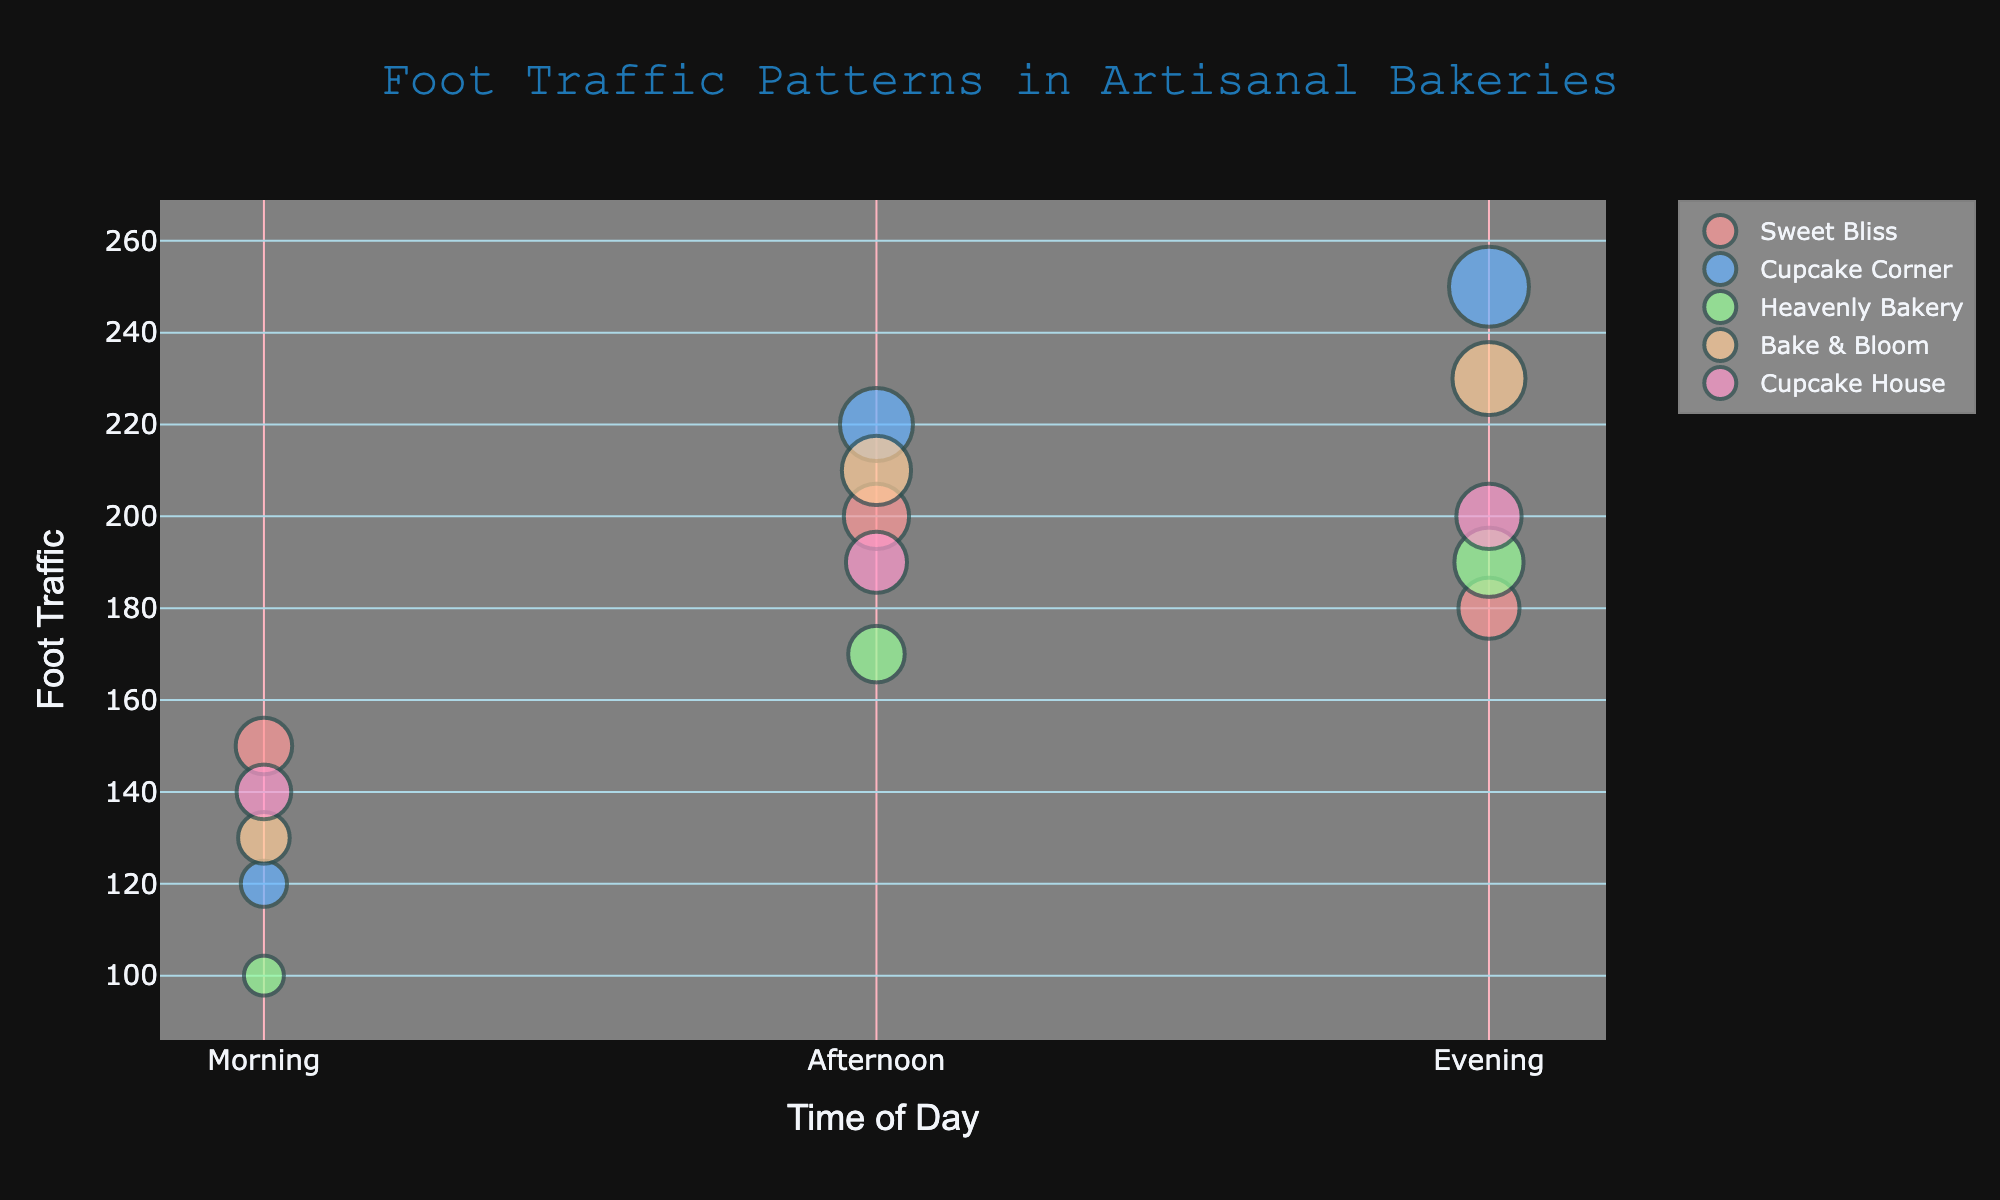What's the title of the figure? Look at the title displayed prominently at the top of the plot.
Answer: Foot Traffic Patterns in Artisanal Bakeries What does the size of the bubbles represent? The legend and the explanatory text on hover indicate the meaning of the bubble size.
Answer: Cupcake Sales Which bakery has the highest foot traffic in the evening? By comparing the positions along the y-axis for the "Evening" entries of each bakery, we see that Cupcake Corner has the highest foot traffic.
Answer: Cupcake Corner What time of day does Sweet Bliss have the highest foot traffic? Locate the markers for Sweet Bliss and compare the y-values for Morning, Afternoon, and Evening times.
Answer: Afternoon Which bakery has the smallest bubble in the morning session? Compare the sizes of the bubbles at the "Morning" time for each bakery. The smallest bubble indicates the lowest cupcake sales.
Answer: Heavenly Bakery What trend can be observed in foot traffic for Bake & Bloom throughout the day? Analyze the y-values for Bake & Bloom at different times of the day to identify any increasing or decreasing trends.
Answer: Increasing How much does foot traffic increase for Cupcake Corner from morning to afternoon? Look at the y-values for Cupcake Corner in the "Morning" and "Afternoon". Calculate the difference. 220 (Afternoon) - 120 (Morning) = 100
Answer: 100 Which bakery has the largest cupcake sales in the afternoon, and what is the bubble size? Compare the sizes of the bubbles at the "Afternoon" time for each bakery. The largest bubble corresponds to the highest cupcake sales.
Answer: Cupcake Corner, 50 How do cupcake sales at Cupcake House compare between morning and evening? Compare the sizes of the bubbles for Cupcake House at "Morning" and "Evening". The bubble sizes represent cupcake sales.
Answer: Higher in the Evening What is the range of foot traffic for all bakeries in the evening? Identify the minimum and maximum y-values for the evening times for all bakeries and calculate the range. The minimum is 180 for Sweet Bliss and the maximum is 250 for Cupcake Corner. Range = 250 - 180 = 70
Answer: 70 